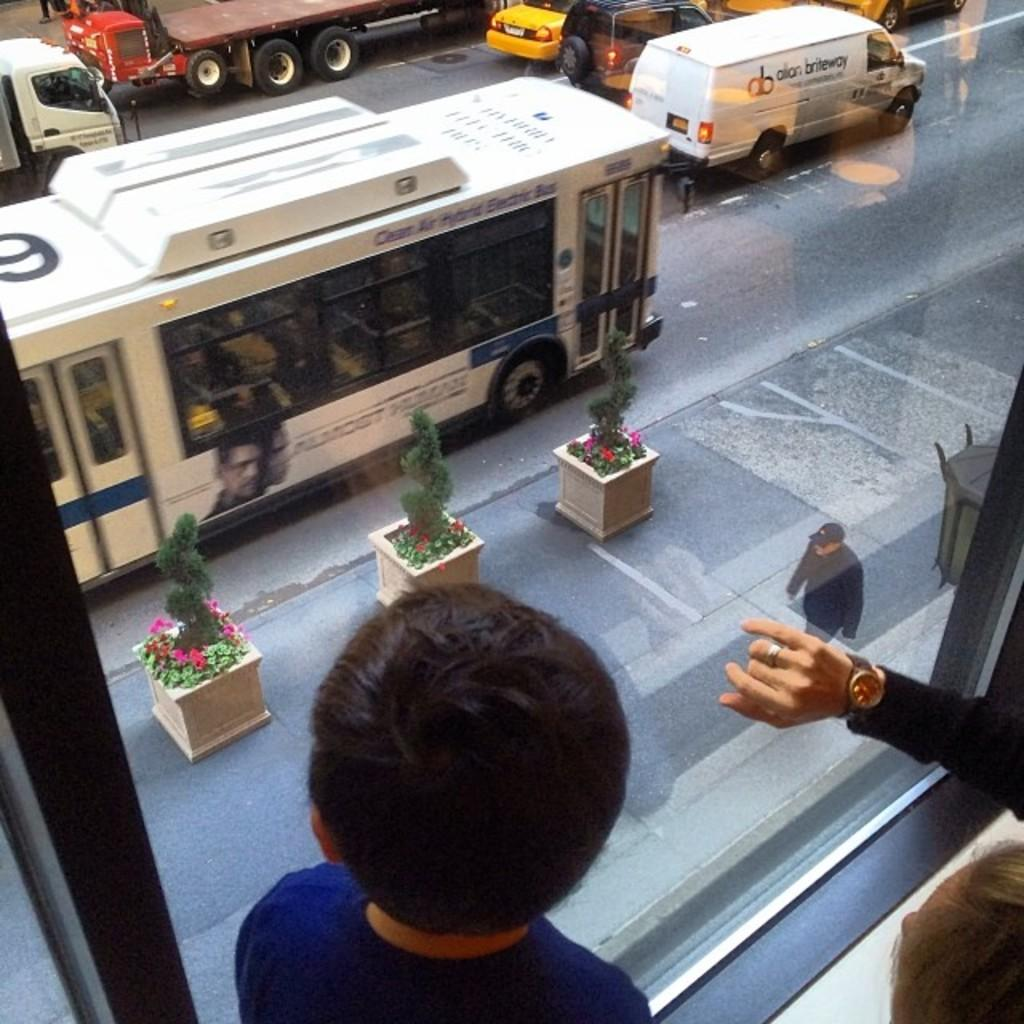How many people are in the image? There are a few people in the image. What is the primary feature of the window in the image? There is a glass window in the image. What can be seen on the ground in the image? The ground is visible in the image. What type of vegetation is present in the image? There are plants and flowers in the image. What type of transportation can be seen in the image? There are a few vehicles in the image. Can you describe the unspecified object in the image? Unfortunately, the facts provided do not specify the nature of the unspecified object in the image. How many matches are needed to solve the riddle in the image? There is no riddle present in the image, so it is not possible to determine how many matches would be needed to solve it. 